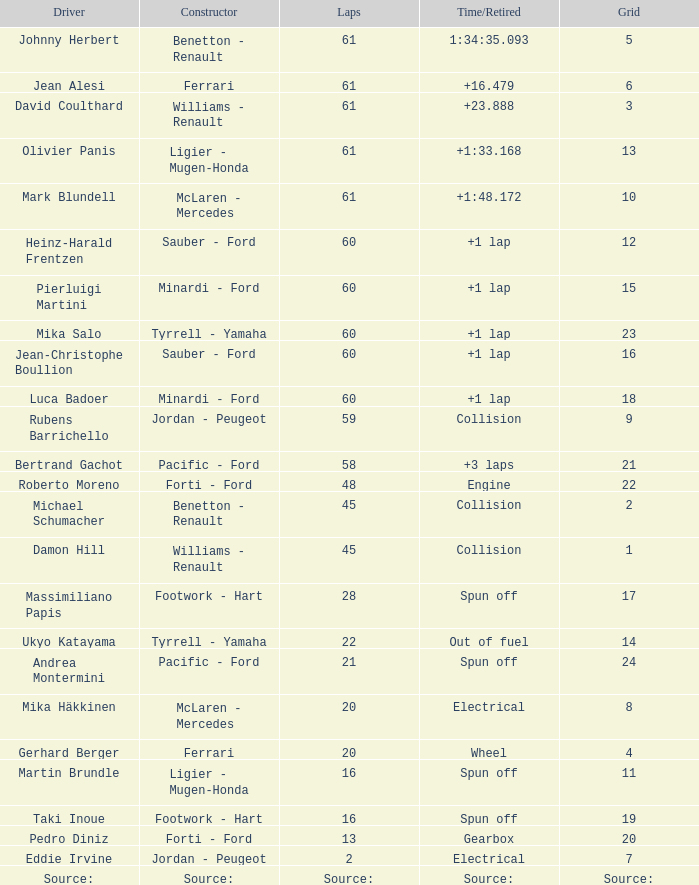Which grid includes 2 loops? 7.0. 